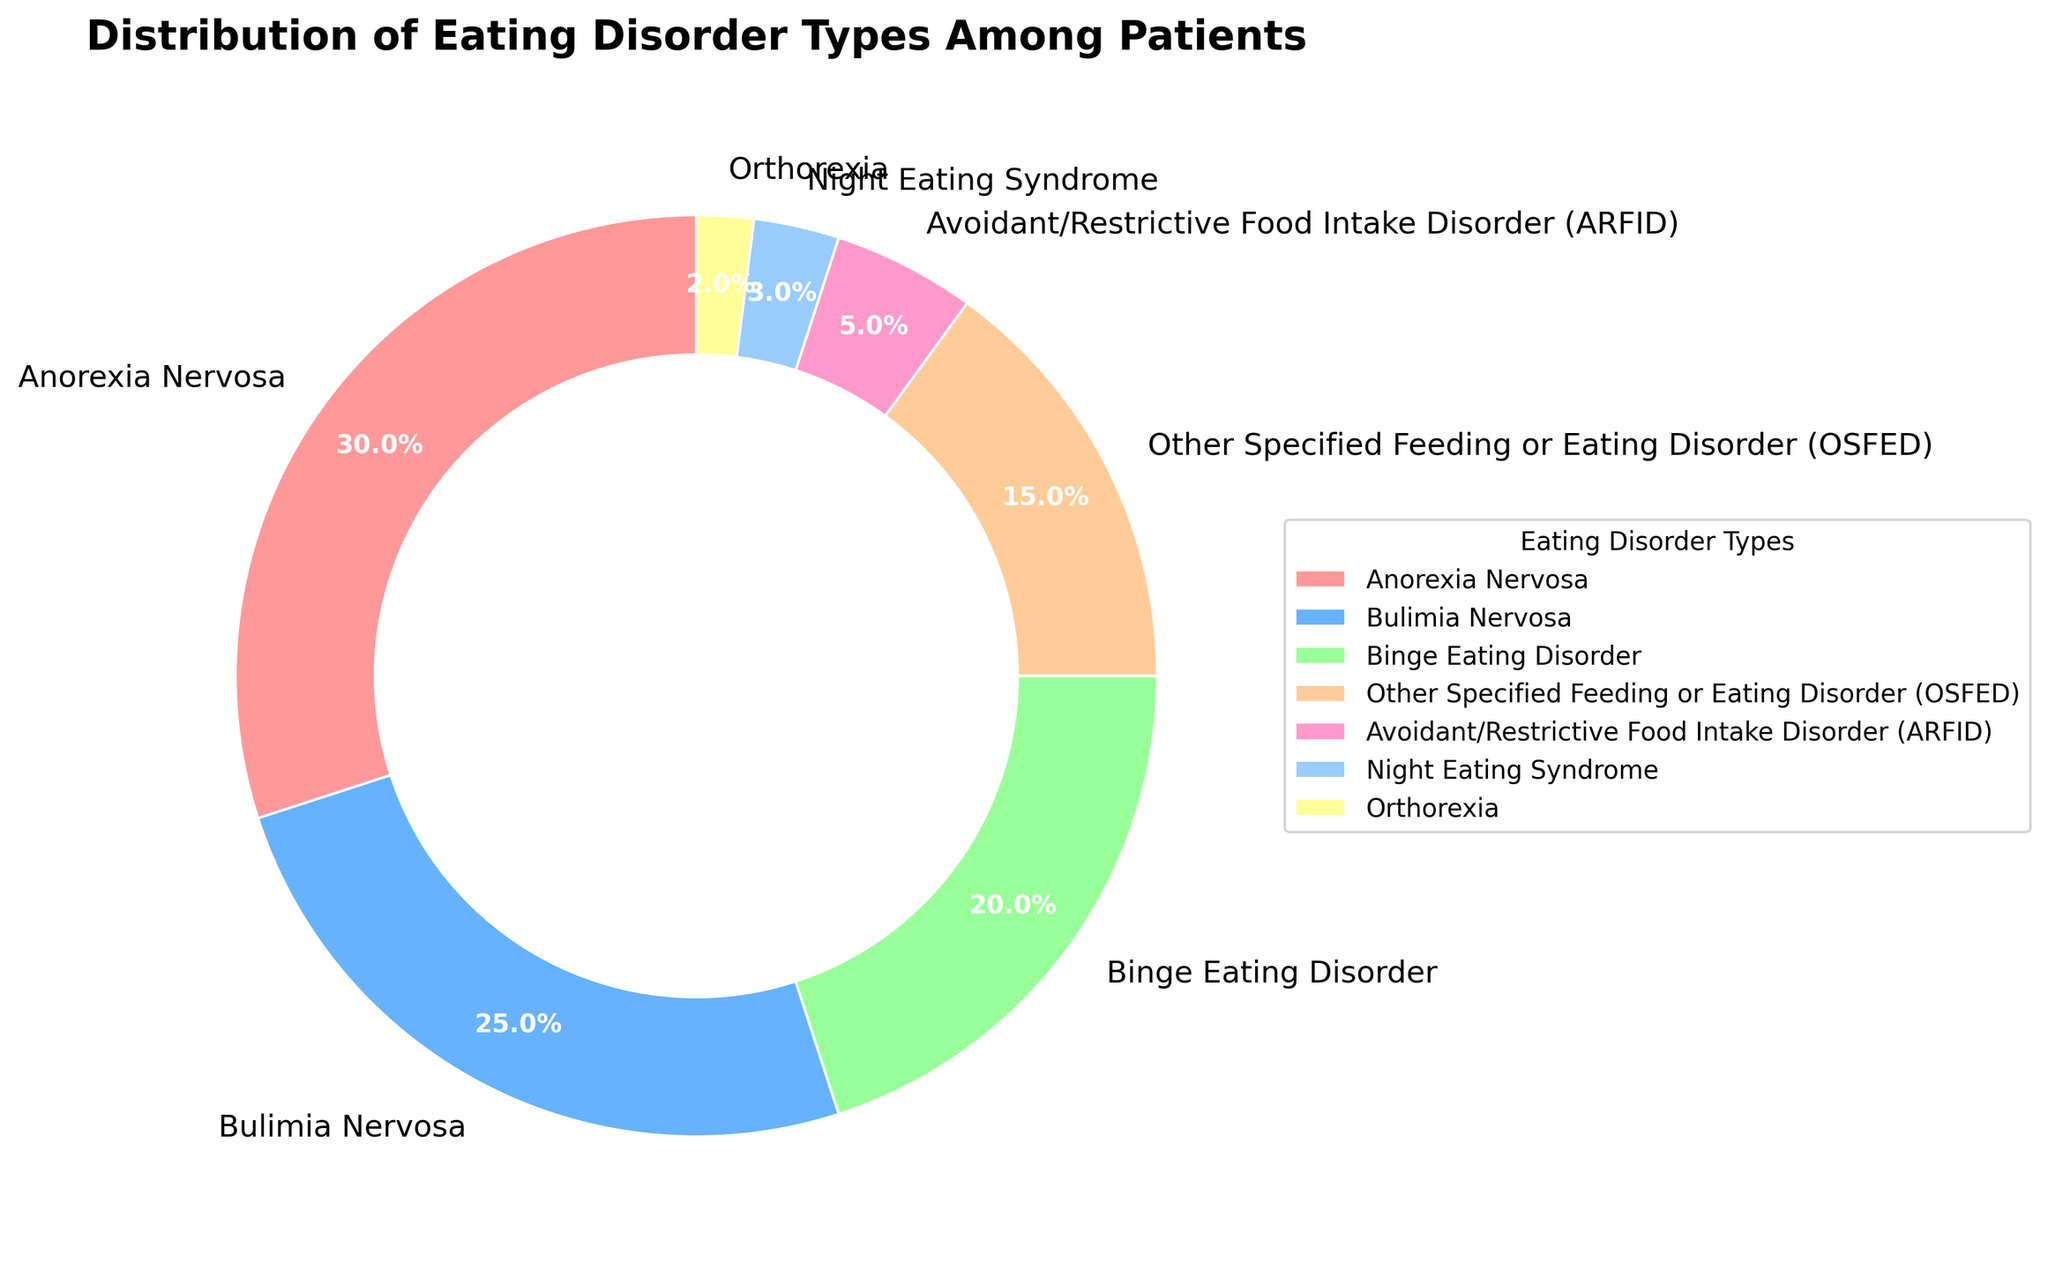What percentage of patients are diagnosed with Anorexia Nervosa and Bulimia Nervosa combined? To find the combined percentage of patients diagnosed with these two disorders, we sum their individual percentages: 30% (Anorexia Nervosa) + 25% (Bulimia Nervosa) = 55%.
Answer: 55% Which eating disorder type has the smallest percentage of patients? The chart shows that Orthorexia has the smallest percentage of patients, with a value of 2%.
Answer: Orthorexia How does the percentage of patients with Binge Eating Disorder compare to those with OSFED? To compare the percentages, we see that Binge Eating Disorder has 20% and OSFED has 15%. Therefore, Binge Eating Disorder has a higher percentage.
Answer: Binge Eating Disorder What is the difference in percentages between patients with ARFID and Night Eating Syndrome? ARFID has 5% of patients and Night Eating Syndrome has 3%. The difference is 5% - 3% = 2%.
Answer: 2% Which eating disorder types together make up just over half of the total percentage? Anorexia Nervosa (30%) and Bulimia Nervosa (25%) together sum to 55%, which is just over half of the total percentage.
Answer: Anorexia Nervosa and Bulimia Nervosa Order the eating disorder types in descending order of their percentages. The percentages in descending order are: Anorexia Nervosa (30%), Bulimia Nervosa (25%), Binge Eating Disorder (20%), OSFED (15%), ARFID (5%), Night Eating Syndrome (3%), Orthorexia (2%).
Answer: Anorexia Nervosa, Bulimia Nervosa, Binge Eating Disorder, OSFED, ARFID, Night Eating Syndrome, Orthorexia What percentage of patients have non-specific eating disorders (OSFED + ARFID)? OSFED has 15% and ARFID has 5%, adding these two gives 15% + 5% = 20%.
Answer: 20% Which color represents Bulimia Nervosa? Bulimia Nervosa is represented by the blue-colored section in the pie chart.
Answer: Blue Is the number of patients with Binge Eating Disorder more than double those with ARFID? The percentage for Binge Eating Disorder is 20% and for ARFID is 5%. Since 20% is more than twice the 5% of ARFID, the answer is yes.
Answer: Yes How many eating disorder types comprise less than 10% of the total patient percentage? The disorder types comprising less than 10% are ARFID (5%), Night Eating Syndrome (3%), and Orthorexia (2%). Thus, there are 3 types.
Answer: 3 